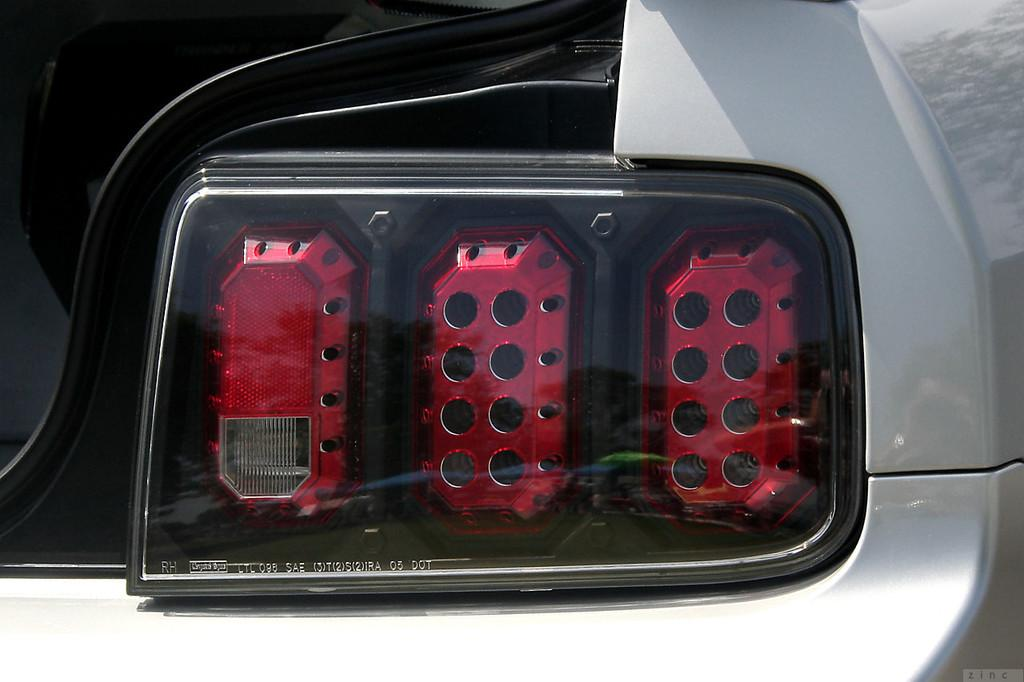What is the main subject of the image? There is a vehicle in the image. Can you describe any specific features of the vehicle? Unfortunately, the provided facts do not mention any specific features of the vehicle. Are there any other elements visible in the image besides the vehicle? Yes, there are lights visible in the image. What type of advertisement can be seen on the vehicle in the image? There is no advertisement visible on the vehicle in the image. Can you tell me where the mom is located in the image? There is no mention of a mom or any person in the image. 